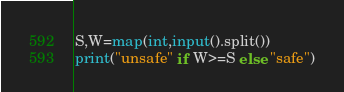Convert code to text. <code><loc_0><loc_0><loc_500><loc_500><_Python_>S,W=map(int,input().split())
print("unsafe" if W>=S else "safe")</code> 